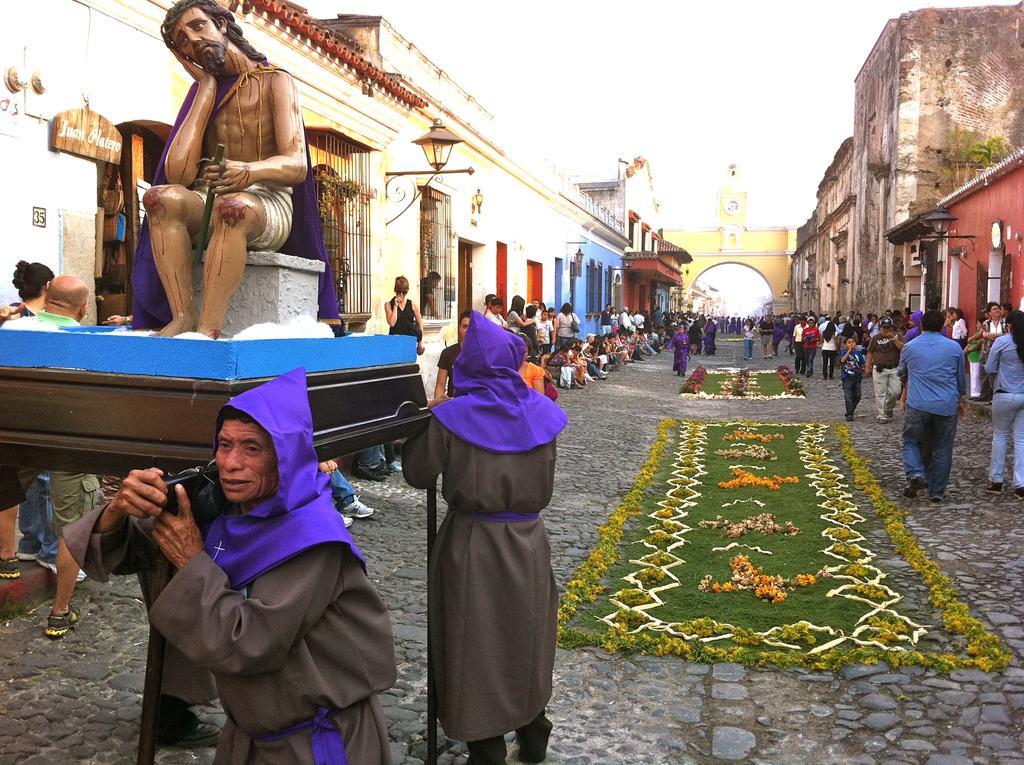Could you give a brief overview of what you see in this image? In the picture I can see buildings, people among them the people in the front carrying a statue of the Jesus and some other objects. In the background I can see flowers, street lights, the sky and some other objects. 